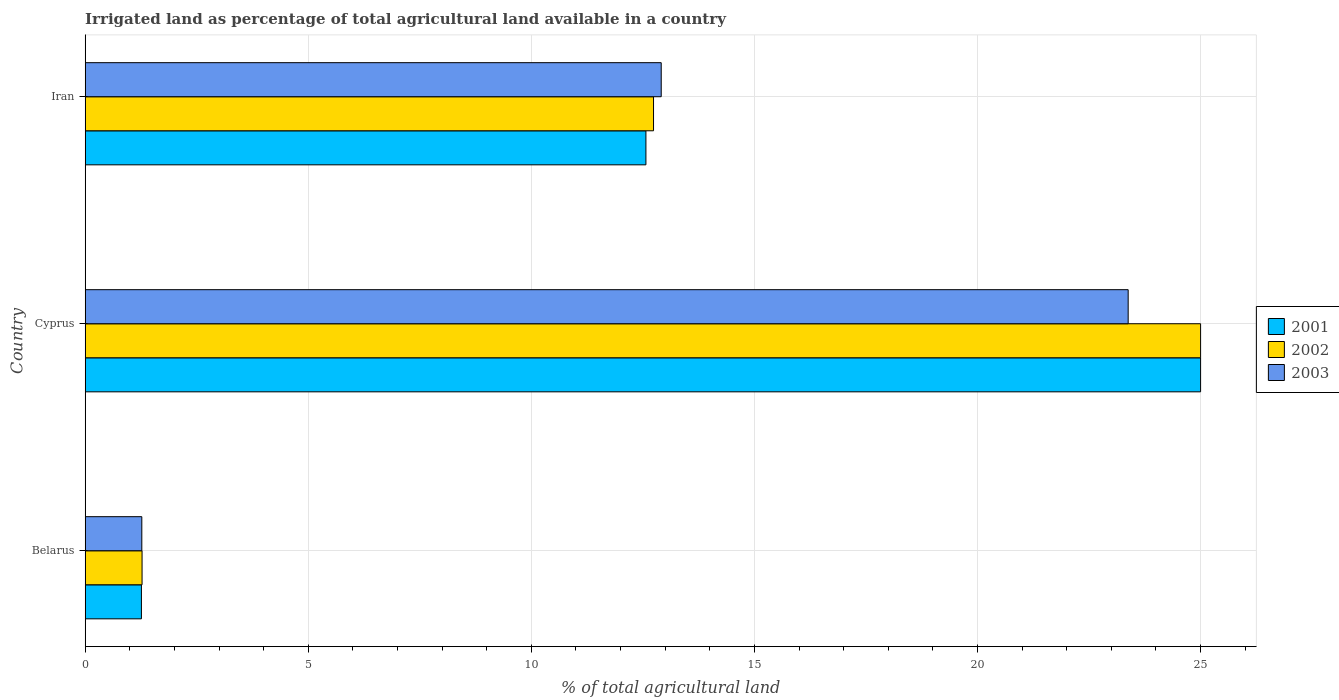Are the number of bars per tick equal to the number of legend labels?
Your answer should be compact. Yes. How many bars are there on the 3rd tick from the top?
Make the answer very short. 3. What is the label of the 1st group of bars from the top?
Ensure brevity in your answer.  Iran. What is the percentage of irrigated land in 2002 in Belarus?
Give a very brief answer. 1.27. Across all countries, what is the maximum percentage of irrigated land in 2002?
Your answer should be compact. 25. Across all countries, what is the minimum percentage of irrigated land in 2002?
Keep it short and to the point. 1.27. In which country was the percentage of irrigated land in 2002 maximum?
Keep it short and to the point. Cyprus. In which country was the percentage of irrigated land in 2002 minimum?
Make the answer very short. Belarus. What is the total percentage of irrigated land in 2001 in the graph?
Your answer should be very brief. 38.83. What is the difference between the percentage of irrigated land in 2003 in Belarus and that in Iran?
Give a very brief answer. -11.64. What is the difference between the percentage of irrigated land in 2001 in Belarus and the percentage of irrigated land in 2002 in Cyprus?
Offer a very short reply. -23.74. What is the average percentage of irrigated land in 2003 per country?
Ensure brevity in your answer.  12.52. What is the difference between the percentage of irrigated land in 2003 and percentage of irrigated land in 2002 in Cyprus?
Give a very brief answer. -1.62. What is the ratio of the percentage of irrigated land in 2003 in Belarus to that in Cyprus?
Your answer should be compact. 0.05. What is the difference between the highest and the second highest percentage of irrigated land in 2001?
Provide a short and direct response. 12.43. What is the difference between the highest and the lowest percentage of irrigated land in 2002?
Your response must be concise. 23.73. In how many countries, is the percentage of irrigated land in 2002 greater than the average percentage of irrigated land in 2002 taken over all countries?
Offer a very short reply. 1. Is the sum of the percentage of irrigated land in 2003 in Cyprus and Iran greater than the maximum percentage of irrigated land in 2001 across all countries?
Ensure brevity in your answer.  Yes. What does the 3rd bar from the top in Iran represents?
Provide a succinct answer. 2001. Is it the case that in every country, the sum of the percentage of irrigated land in 2001 and percentage of irrigated land in 2002 is greater than the percentage of irrigated land in 2003?
Your answer should be compact. Yes. Are all the bars in the graph horizontal?
Make the answer very short. Yes. How many countries are there in the graph?
Offer a terse response. 3. Are the values on the major ticks of X-axis written in scientific E-notation?
Give a very brief answer. No. Does the graph contain any zero values?
Your answer should be compact. No. Where does the legend appear in the graph?
Offer a very short reply. Center right. What is the title of the graph?
Keep it short and to the point. Irrigated land as percentage of total agricultural land available in a country. Does "1989" appear as one of the legend labels in the graph?
Ensure brevity in your answer.  No. What is the label or title of the X-axis?
Keep it short and to the point. % of total agricultural land. What is the label or title of the Y-axis?
Your answer should be very brief. Country. What is the % of total agricultural land in 2001 in Belarus?
Offer a terse response. 1.26. What is the % of total agricultural land of 2002 in Belarus?
Offer a very short reply. 1.27. What is the % of total agricultural land of 2003 in Belarus?
Your response must be concise. 1.27. What is the % of total agricultural land of 2001 in Cyprus?
Provide a succinct answer. 25. What is the % of total agricultural land in 2002 in Cyprus?
Give a very brief answer. 25. What is the % of total agricultural land in 2003 in Cyprus?
Your answer should be compact. 23.38. What is the % of total agricultural land in 2001 in Iran?
Provide a short and direct response. 12.57. What is the % of total agricultural land of 2002 in Iran?
Offer a terse response. 12.74. What is the % of total agricultural land in 2003 in Iran?
Provide a short and direct response. 12.91. Across all countries, what is the maximum % of total agricultural land in 2002?
Offer a terse response. 25. Across all countries, what is the maximum % of total agricultural land in 2003?
Your answer should be very brief. 23.38. Across all countries, what is the minimum % of total agricultural land in 2001?
Give a very brief answer. 1.26. Across all countries, what is the minimum % of total agricultural land in 2002?
Keep it short and to the point. 1.27. Across all countries, what is the minimum % of total agricultural land in 2003?
Give a very brief answer. 1.27. What is the total % of total agricultural land of 2001 in the graph?
Keep it short and to the point. 38.83. What is the total % of total agricultural land in 2002 in the graph?
Provide a short and direct response. 39.01. What is the total % of total agricultural land of 2003 in the graph?
Keep it short and to the point. 37.56. What is the difference between the % of total agricultural land of 2001 in Belarus and that in Cyprus?
Make the answer very short. -23.74. What is the difference between the % of total agricultural land of 2002 in Belarus and that in Cyprus?
Keep it short and to the point. -23.73. What is the difference between the % of total agricultural land in 2003 in Belarus and that in Cyprus?
Ensure brevity in your answer.  -22.11. What is the difference between the % of total agricultural land of 2001 in Belarus and that in Iran?
Provide a succinct answer. -11.31. What is the difference between the % of total agricultural land in 2002 in Belarus and that in Iran?
Your answer should be compact. -11.46. What is the difference between the % of total agricultural land of 2003 in Belarus and that in Iran?
Offer a terse response. -11.64. What is the difference between the % of total agricultural land in 2001 in Cyprus and that in Iran?
Offer a terse response. 12.43. What is the difference between the % of total agricultural land of 2002 in Cyprus and that in Iran?
Offer a terse response. 12.26. What is the difference between the % of total agricultural land in 2003 in Cyprus and that in Iran?
Give a very brief answer. 10.47. What is the difference between the % of total agricultural land in 2001 in Belarus and the % of total agricultural land in 2002 in Cyprus?
Provide a succinct answer. -23.74. What is the difference between the % of total agricultural land in 2001 in Belarus and the % of total agricultural land in 2003 in Cyprus?
Provide a succinct answer. -22.12. What is the difference between the % of total agricultural land of 2002 in Belarus and the % of total agricultural land of 2003 in Cyprus?
Make the answer very short. -22.1. What is the difference between the % of total agricultural land of 2001 in Belarus and the % of total agricultural land of 2002 in Iran?
Your answer should be compact. -11.48. What is the difference between the % of total agricultural land in 2001 in Belarus and the % of total agricultural land in 2003 in Iran?
Your answer should be compact. -11.65. What is the difference between the % of total agricultural land of 2002 in Belarus and the % of total agricultural land of 2003 in Iran?
Your response must be concise. -11.64. What is the difference between the % of total agricultural land of 2001 in Cyprus and the % of total agricultural land of 2002 in Iran?
Your response must be concise. 12.26. What is the difference between the % of total agricultural land of 2001 in Cyprus and the % of total agricultural land of 2003 in Iran?
Ensure brevity in your answer.  12.09. What is the difference between the % of total agricultural land in 2002 in Cyprus and the % of total agricultural land in 2003 in Iran?
Provide a short and direct response. 12.09. What is the average % of total agricultural land of 2001 per country?
Provide a short and direct response. 12.94. What is the average % of total agricultural land of 2002 per country?
Provide a succinct answer. 13. What is the average % of total agricultural land in 2003 per country?
Your response must be concise. 12.52. What is the difference between the % of total agricultural land in 2001 and % of total agricultural land in 2002 in Belarus?
Provide a short and direct response. -0.01. What is the difference between the % of total agricultural land of 2001 and % of total agricultural land of 2003 in Belarus?
Offer a very short reply. -0.01. What is the difference between the % of total agricultural land of 2002 and % of total agricultural land of 2003 in Belarus?
Your answer should be compact. 0.01. What is the difference between the % of total agricultural land of 2001 and % of total agricultural land of 2003 in Cyprus?
Provide a short and direct response. 1.62. What is the difference between the % of total agricultural land in 2002 and % of total agricultural land in 2003 in Cyprus?
Offer a terse response. 1.62. What is the difference between the % of total agricultural land in 2001 and % of total agricultural land in 2002 in Iran?
Provide a short and direct response. -0.17. What is the difference between the % of total agricultural land in 2001 and % of total agricultural land in 2003 in Iran?
Keep it short and to the point. -0.34. What is the difference between the % of total agricultural land of 2002 and % of total agricultural land of 2003 in Iran?
Offer a terse response. -0.17. What is the ratio of the % of total agricultural land in 2001 in Belarus to that in Cyprus?
Ensure brevity in your answer.  0.05. What is the ratio of the % of total agricultural land in 2002 in Belarus to that in Cyprus?
Your answer should be compact. 0.05. What is the ratio of the % of total agricultural land in 2003 in Belarus to that in Cyprus?
Your answer should be very brief. 0.05. What is the ratio of the % of total agricultural land in 2001 in Belarus to that in Iran?
Offer a terse response. 0.1. What is the ratio of the % of total agricultural land in 2003 in Belarus to that in Iran?
Your answer should be compact. 0.1. What is the ratio of the % of total agricultural land in 2001 in Cyprus to that in Iran?
Your answer should be compact. 1.99. What is the ratio of the % of total agricultural land of 2002 in Cyprus to that in Iran?
Keep it short and to the point. 1.96. What is the ratio of the % of total agricultural land in 2003 in Cyprus to that in Iran?
Your answer should be compact. 1.81. What is the difference between the highest and the second highest % of total agricultural land of 2001?
Make the answer very short. 12.43. What is the difference between the highest and the second highest % of total agricultural land of 2002?
Your response must be concise. 12.26. What is the difference between the highest and the second highest % of total agricultural land in 2003?
Provide a short and direct response. 10.47. What is the difference between the highest and the lowest % of total agricultural land of 2001?
Offer a terse response. 23.74. What is the difference between the highest and the lowest % of total agricultural land in 2002?
Make the answer very short. 23.73. What is the difference between the highest and the lowest % of total agricultural land in 2003?
Offer a very short reply. 22.11. 